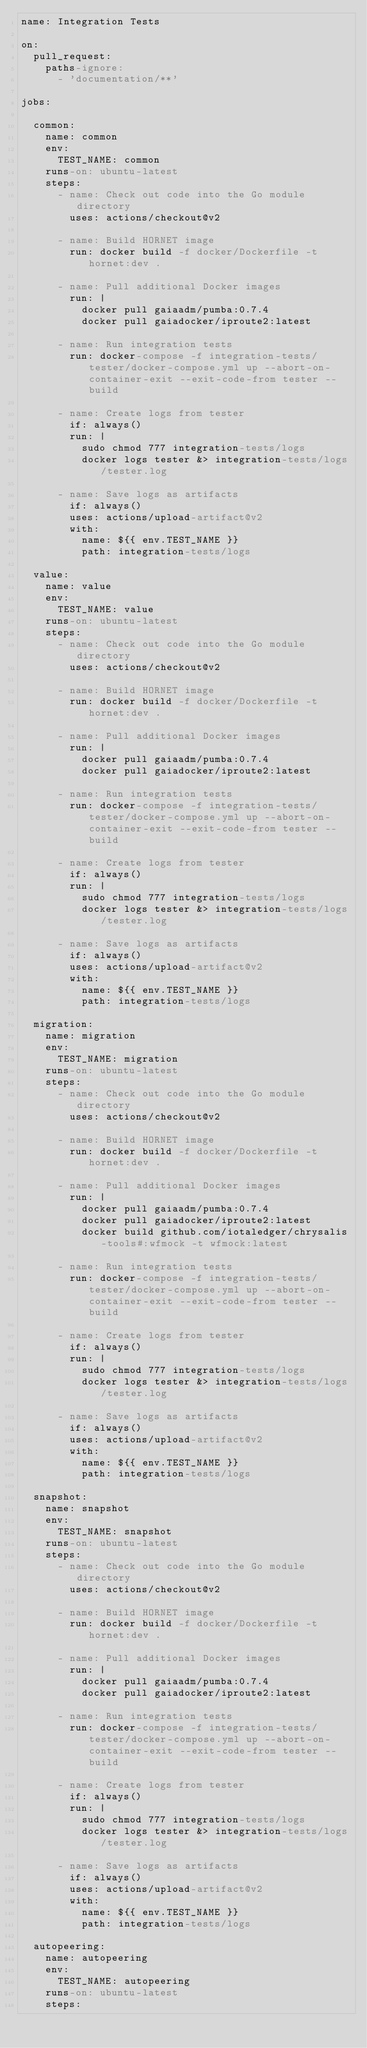Convert code to text. <code><loc_0><loc_0><loc_500><loc_500><_YAML_>name: Integration Tests

on:
  pull_request:
    paths-ignore:
      - 'documentation/**'

jobs:

  common:
    name: common
    env:
      TEST_NAME: common
    runs-on: ubuntu-latest
    steps:
      - name: Check out code into the Go module directory
        uses: actions/checkout@v2

      - name: Build HORNET image
        run: docker build -f docker/Dockerfile -t hornet:dev .

      - name: Pull additional Docker images
        run: |
          docker pull gaiaadm/pumba:0.7.4
          docker pull gaiadocker/iproute2:latest

      - name: Run integration tests
        run: docker-compose -f integration-tests/tester/docker-compose.yml up --abort-on-container-exit --exit-code-from tester --build

      - name: Create logs from tester
        if: always()
        run: |
          sudo chmod 777 integration-tests/logs
          docker logs tester &> integration-tests/logs/tester.log

      - name: Save logs as artifacts
        if: always()
        uses: actions/upload-artifact@v2
        with:
          name: ${{ env.TEST_NAME }}
          path: integration-tests/logs

  value:
    name: value
    env:
      TEST_NAME: value
    runs-on: ubuntu-latest
    steps:
      - name: Check out code into the Go module directory
        uses: actions/checkout@v2

      - name: Build HORNET image
        run: docker build -f docker/Dockerfile -t hornet:dev .

      - name: Pull additional Docker images
        run: |
          docker pull gaiaadm/pumba:0.7.4
          docker pull gaiadocker/iproute2:latest

      - name: Run integration tests
        run: docker-compose -f integration-tests/tester/docker-compose.yml up --abort-on-container-exit --exit-code-from tester --build

      - name: Create logs from tester
        if: always()
        run: |
          sudo chmod 777 integration-tests/logs
          docker logs tester &> integration-tests/logs/tester.log

      - name: Save logs as artifacts
        if: always()
        uses: actions/upload-artifact@v2
        with:
          name: ${{ env.TEST_NAME }}
          path: integration-tests/logs

  migration:
    name: migration
    env:
      TEST_NAME: migration
    runs-on: ubuntu-latest
    steps:
      - name: Check out code into the Go module directory
        uses: actions/checkout@v2

      - name: Build HORNET image
        run: docker build -f docker/Dockerfile -t hornet:dev .

      - name: Pull additional Docker images
        run: |
          docker pull gaiaadm/pumba:0.7.4
          docker pull gaiadocker/iproute2:latest
          docker build github.com/iotaledger/chrysalis-tools#:wfmock -t wfmock:latest

      - name: Run integration tests
        run: docker-compose -f integration-tests/tester/docker-compose.yml up --abort-on-container-exit --exit-code-from tester --build

      - name: Create logs from tester
        if: always()
        run: |
          sudo chmod 777 integration-tests/logs
          docker logs tester &> integration-tests/logs/tester.log

      - name: Save logs as artifacts
        if: always()
        uses: actions/upload-artifact@v2
        with:
          name: ${{ env.TEST_NAME }}
          path: integration-tests/logs

  snapshot:
    name: snapshot
    env:
      TEST_NAME: snapshot
    runs-on: ubuntu-latest
    steps:
      - name: Check out code into the Go module directory
        uses: actions/checkout@v2

      - name: Build HORNET image
        run: docker build -f docker/Dockerfile -t hornet:dev .

      - name: Pull additional Docker images
        run: |
          docker pull gaiaadm/pumba:0.7.4
          docker pull gaiadocker/iproute2:latest

      - name: Run integration tests
        run: docker-compose -f integration-tests/tester/docker-compose.yml up --abort-on-container-exit --exit-code-from tester --build

      - name: Create logs from tester
        if: always()
        run: |
          sudo chmod 777 integration-tests/logs
          docker logs tester &> integration-tests/logs/tester.log

      - name: Save logs as artifacts
        if: always()
        uses: actions/upload-artifact@v2
        with:
          name: ${{ env.TEST_NAME }}
          path: integration-tests/logs

  autopeering:
    name: autopeering
    env:
      TEST_NAME: autopeering
    runs-on: ubuntu-latest
    steps:</code> 